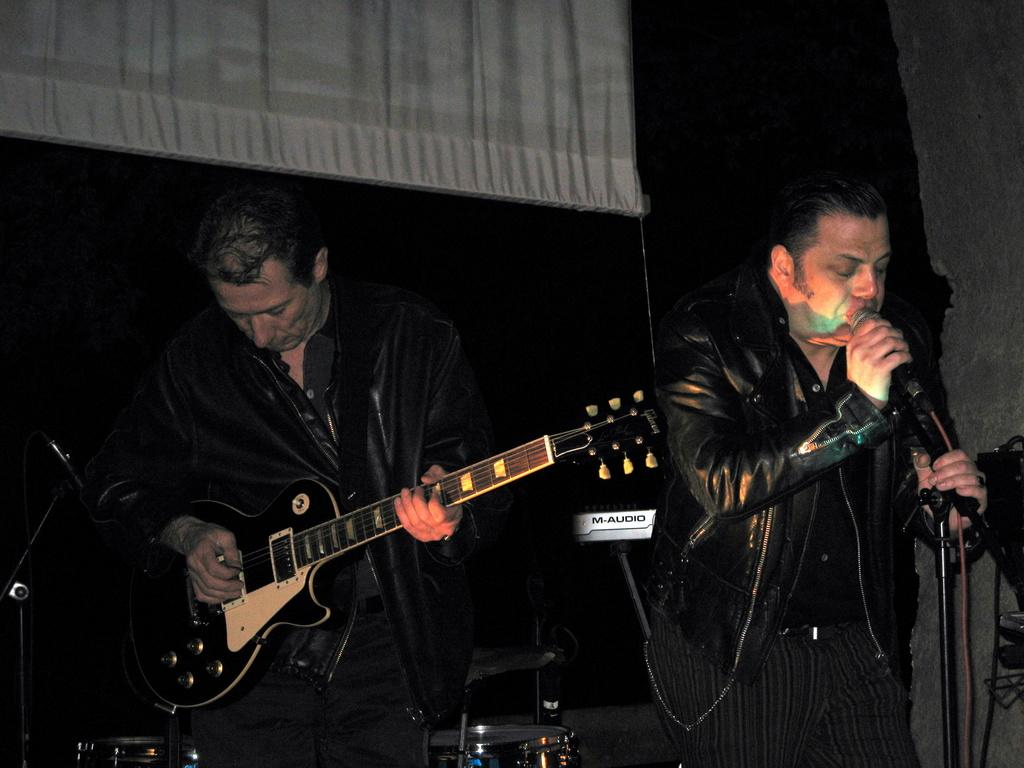What is the man in the image doing? The man is singing in the image. What is the man holding while singing? The man is holding a microphone. What musical instrument is the man playing? The man is playing a guitar. What type of baseball bat is the man using to write a song in the image? There is no baseball bat or writing activity present in the image. The man is singing and playing a guitar. 